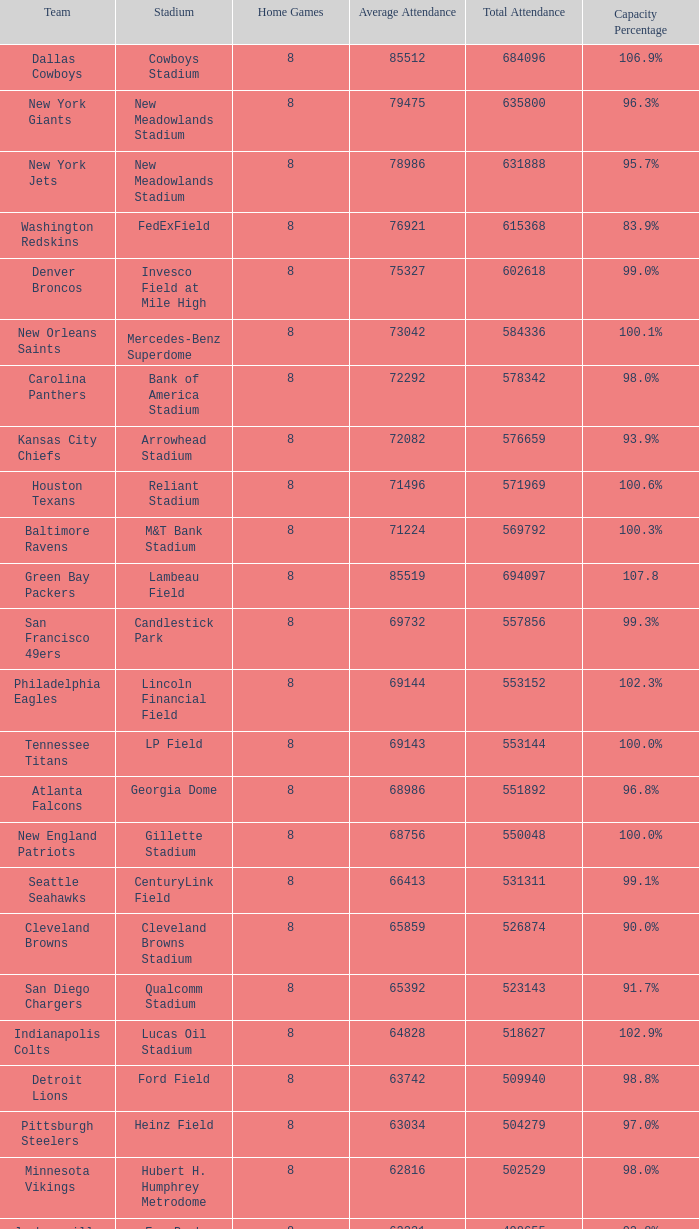5%? 1.0. 